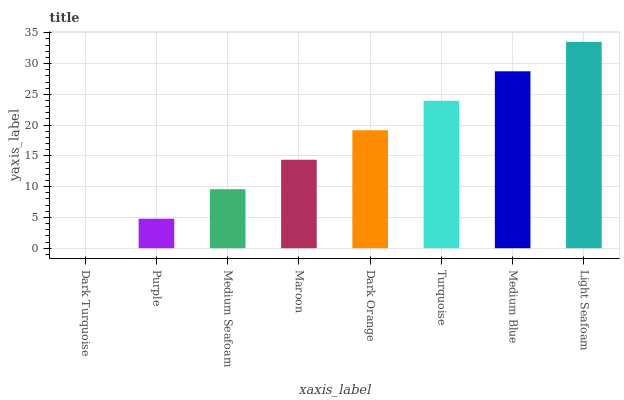Is Dark Turquoise the minimum?
Answer yes or no. Yes. Is Light Seafoam the maximum?
Answer yes or no. Yes. Is Purple the minimum?
Answer yes or no. No. Is Purple the maximum?
Answer yes or no. No. Is Purple greater than Dark Turquoise?
Answer yes or no. Yes. Is Dark Turquoise less than Purple?
Answer yes or no. Yes. Is Dark Turquoise greater than Purple?
Answer yes or no. No. Is Purple less than Dark Turquoise?
Answer yes or no. No. Is Dark Orange the high median?
Answer yes or no. Yes. Is Maroon the low median?
Answer yes or no. Yes. Is Maroon the high median?
Answer yes or no. No. Is Turquoise the low median?
Answer yes or no. No. 